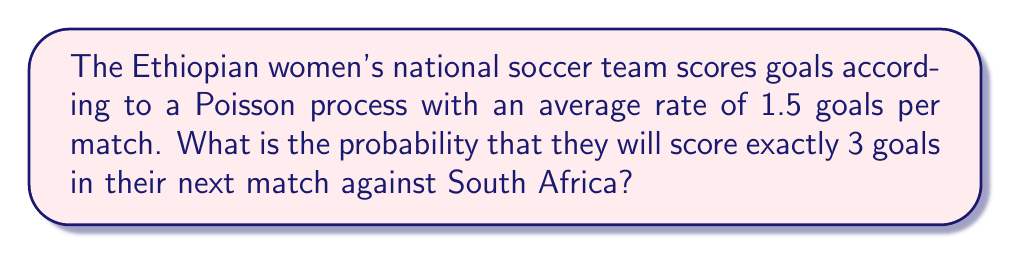What is the answer to this math problem? Let's approach this step-by-step using the Poisson distribution:

1) The Poisson distribution is given by the formula:

   $$P(X = k) = \frac{e^{-\lambda}\lambda^k}{k!}$$

   where:
   - $\lambda$ is the average rate of events (in this case, goals per match)
   - $k$ is the number of events we're interested in (in this case, 3 goals)
   - $e$ is Euler's number (approximately 2.71828)

2) We're given that $\lambda = 1.5$ and we want to find $P(X = 3)$

3) Let's substitute these values into the formula:

   $$P(X = 3) = \frac{e^{-1.5}(1.5)^3}{3!}$$

4) Now, let's calculate each part:
   - $e^{-1.5} \approx 0.22313$
   - $(1.5)^3 = 3.375$
   - $3! = 3 \times 2 \times 1 = 6$

5) Putting it all together:

   $$P(X = 3) = \frac{0.22313 \times 3.375}{6} \approx 0.12520$$

6) Therefore, the probability of the Ethiopian women's team scoring exactly 3 goals in their next match is approximately 0.12520 or 12.52%.
Answer: 0.12520 